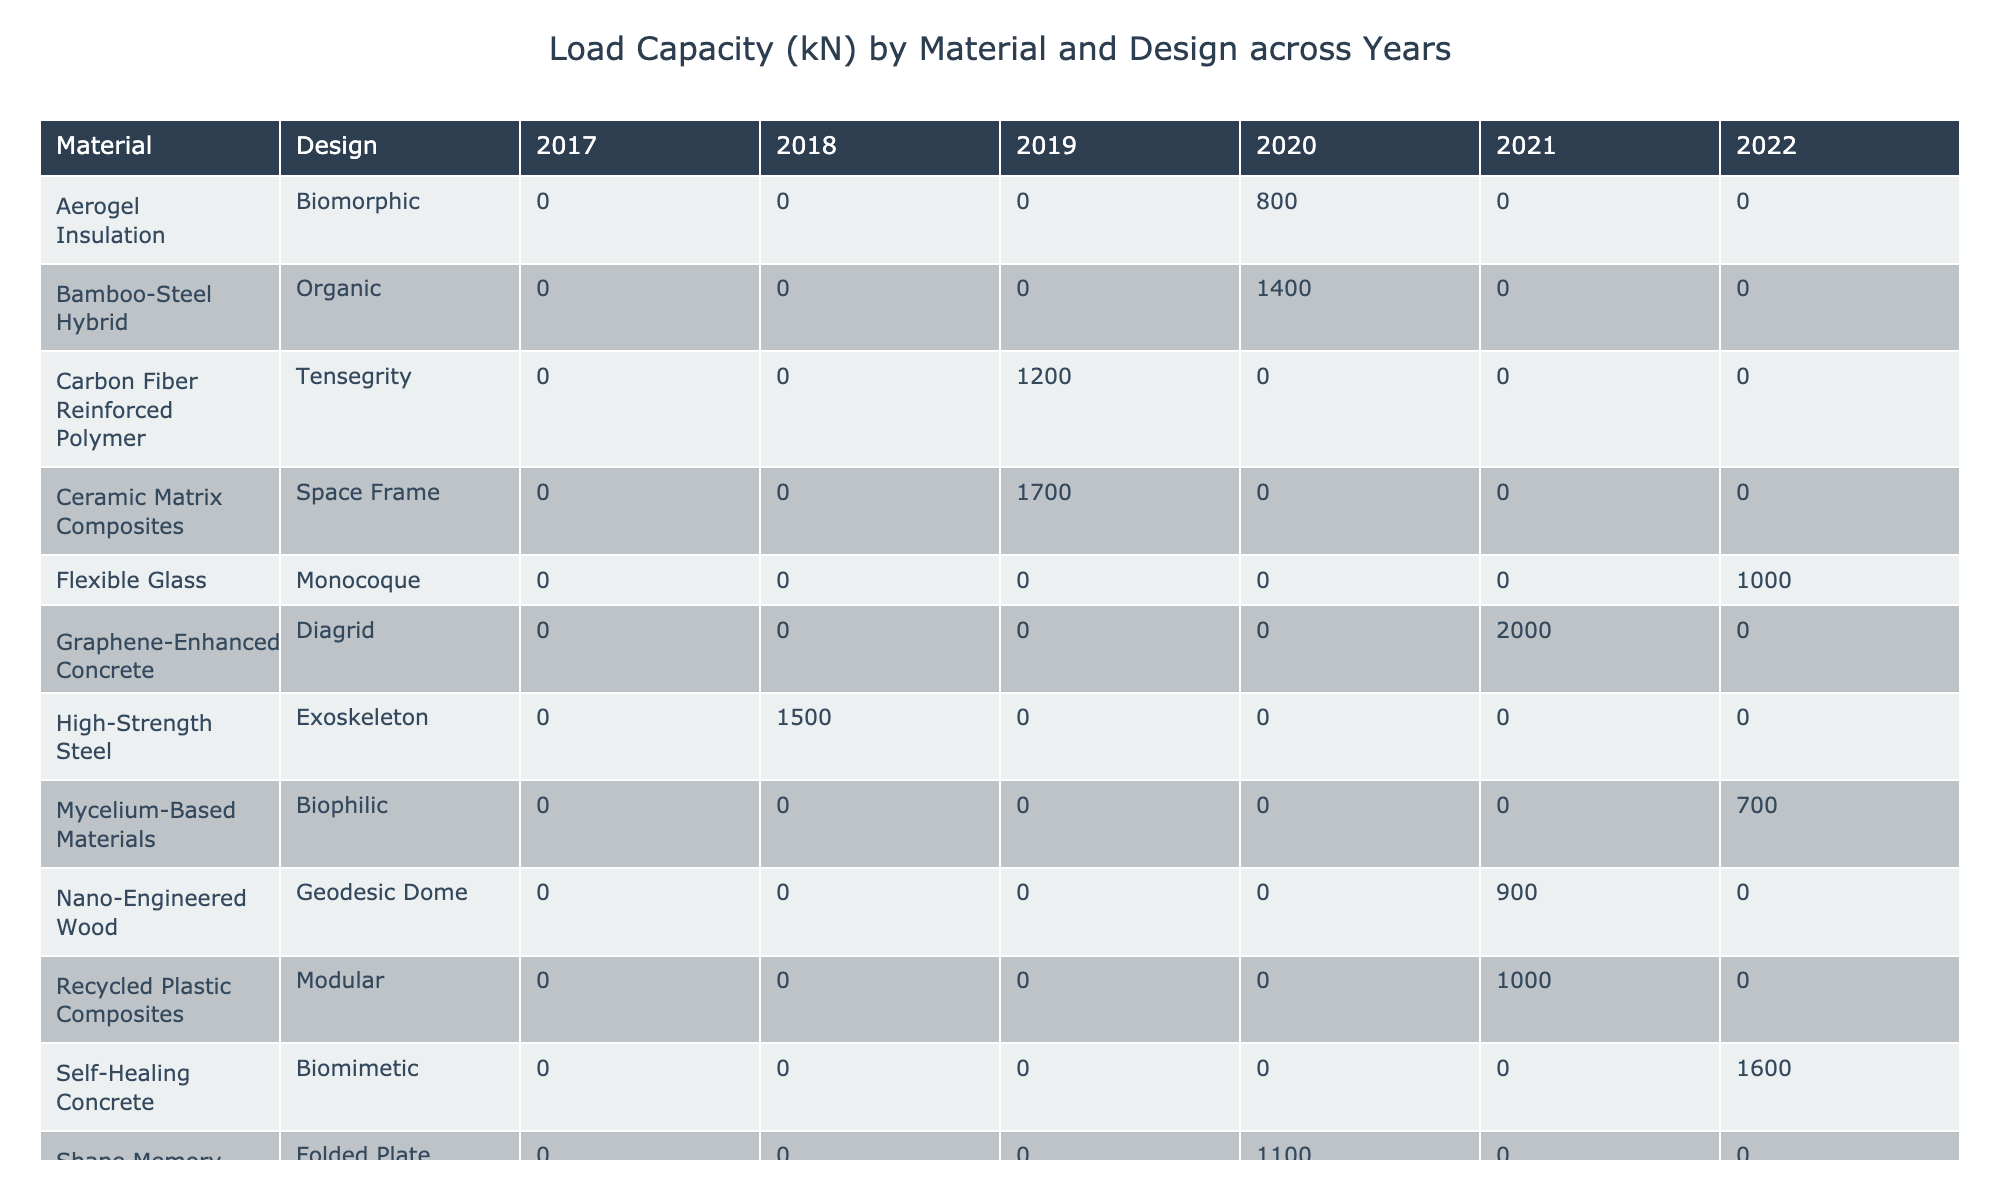What is the highest load capacity recorded in the table? The highest value in the Load Capacity column is found by reviewing all entries. The maximum load capacity from the data is 2200 kN associated with the Ultra-High Performance Concrete design in Shanghai for the year 2018.
Answer: 2200 kN Which design has the lowest durability score? By examining the Durability column, we see that Mycelium-Based Materials have the lowest score at 40 years. This is the only entry with a score lower than others.
Answer: 40 years What is the average load capacity of the designs implemented in 2020? To find the average load capacity for 2020, we identify the designs: Aerogel Insulation (800 kN), Nano-Engineered Wood (900 kN), Self-Healing Concrete (1600 kN), Flexible Glass (1000 kN), and Mycelium-Based Materials (700 kN). Summing these values gives 800 + 900 + 1600 + 1000 + 700 = 4000 kN. Dividing by the total number of designs (5) gives an average load capacity of 4000 / 5 = 800 kN.
Answer: 800 kN Is there a design in the table that has both a high sustainability score and low cost per square meter? Reviewing the table, we see that the Recycled Plastic Composites have a sustainability score of 9.8 and a cost of 450 dollars per m², which meets the criteria of being high in sustainability while low in cost. Thus, there is indeed such a design.
Answer: Yes Which material design has the highest sustainability score? Scanning the Sustainability Score column, Mycelium-Based Materials have the highest score at 9.9. It stands out as having the best sustainability aspect among all designs listed.
Answer: 9.9 